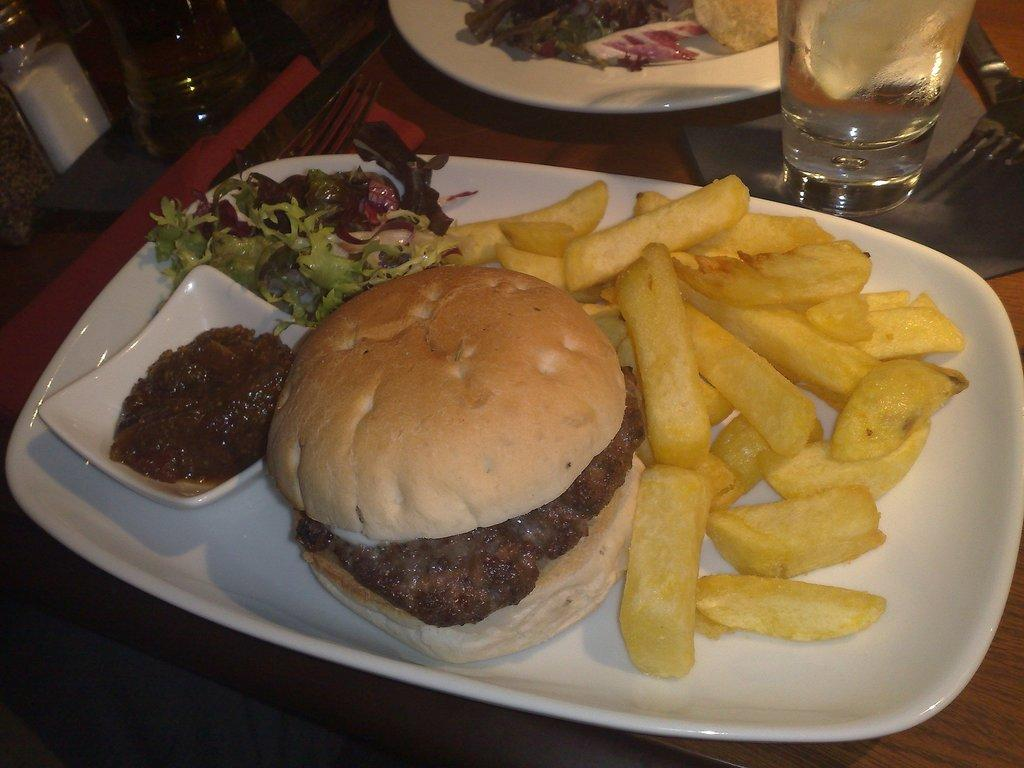What is present on the plates in the image? There are two plates containing food in the image. What type of container is visible in the image? There is a glass in the image. What utensil can be seen in the image? There is a fork in the image. Where are the plates, glass, and fork located? The plates, glass, and fork are placed on a table. What else is present on the table in the image? The bottles are placed at the top of the image. What type of tax is being discussed in the image? There is no discussion of tax in the image; it features plates, a glass, a fork, a table, and bottles. What flavor of cake is visible in the image? There is no cake present in the image. 